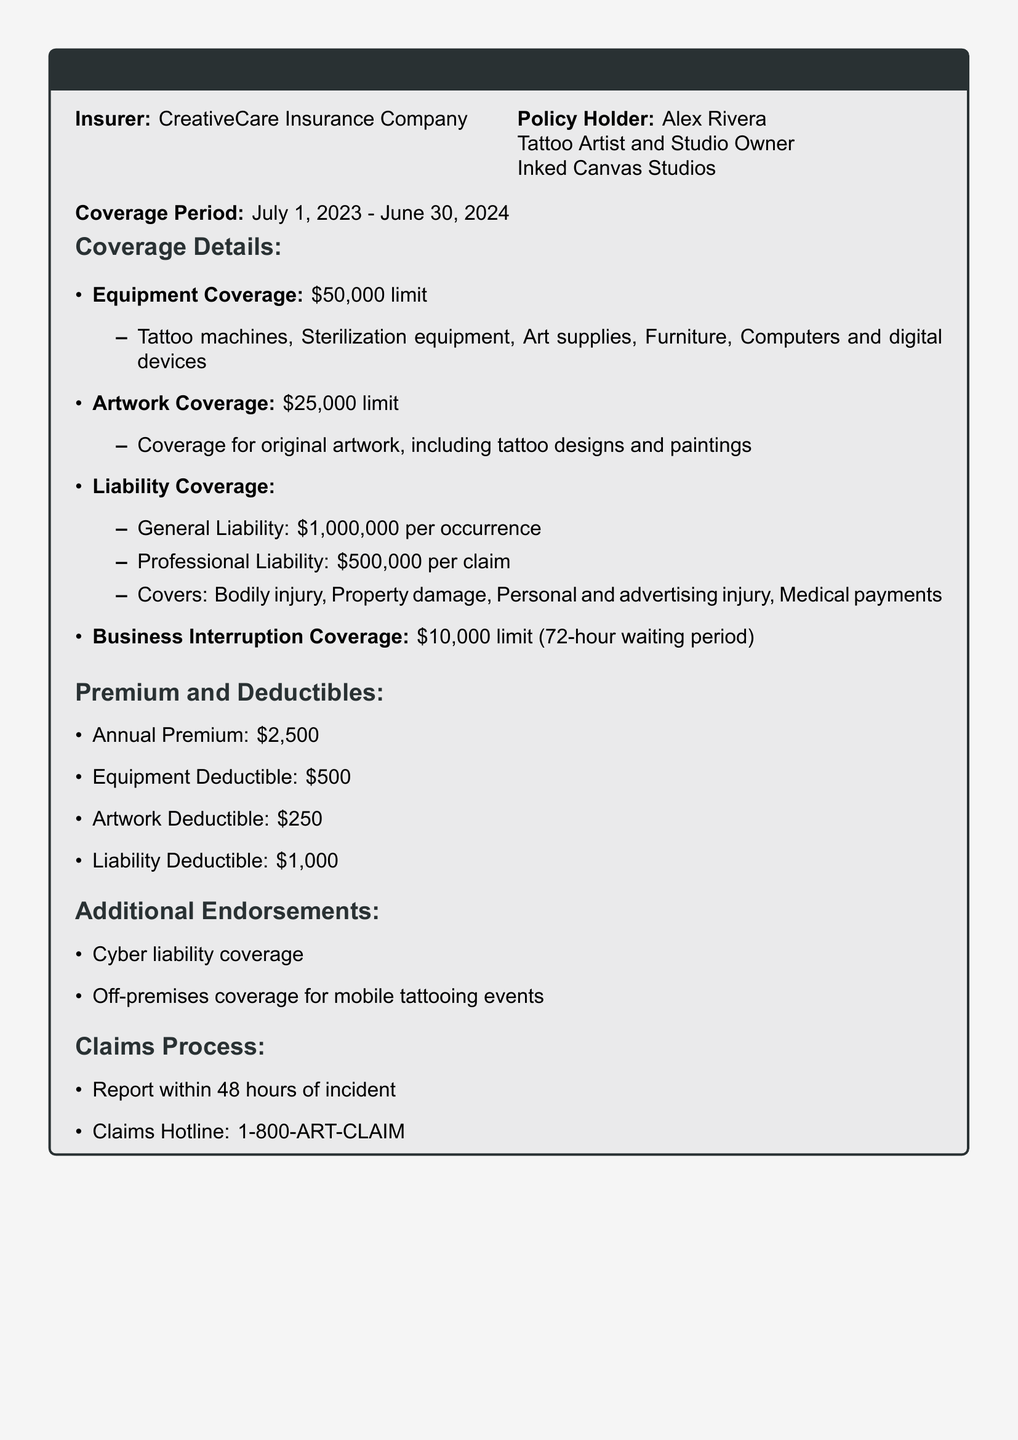What is the insurer's name? The insurer's name is mentioned at the beginning of the document as CreativeCare Insurance Company.
Answer: CreativeCare Insurance Company What is the coverage period? The document specifies the start and end dates of the coverage period.
Answer: July 1, 2023 - June 30, 2024 What is the limit for equipment coverage? The document directly states the financial limit for equipment coverage in the coverage details section.
Answer: $50,000 What is the general liability coverage amount? The general liability coverage amount is specified in the liability coverage section.
Answer: $1,000,000 per occurrence How much is the annual premium? The annual premium is listed under the premium and deductibles section of the document.
Answer: $2,500 What is the deductible for artwork coverage? The deductible amount for artwork coverage is mentioned in the premium and deductibles section.
Answer: $250 What type of additional endorsement covers mobile tattooing events? The document mentions an endorsement specifically for mobile tattooing events in the additional endorsements section.
Answer: Off-premises coverage How long is the waiting period for business interruption coverage? The waiting period for business interruption coverage is specified in the coverage details section.
Answer: 72-hour waiting period What should you do within 48 hours of an incident? The claims process section outlines the actions required after an incident.
Answer: Report the incident 